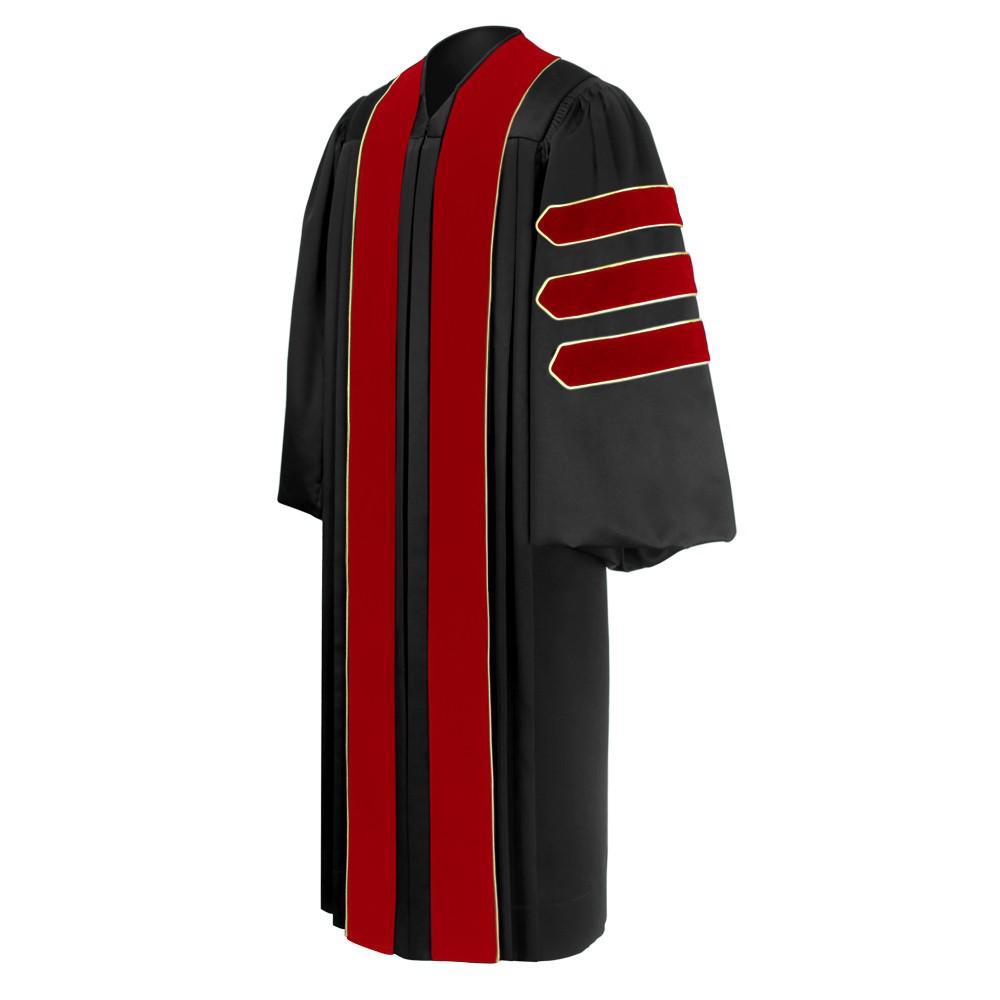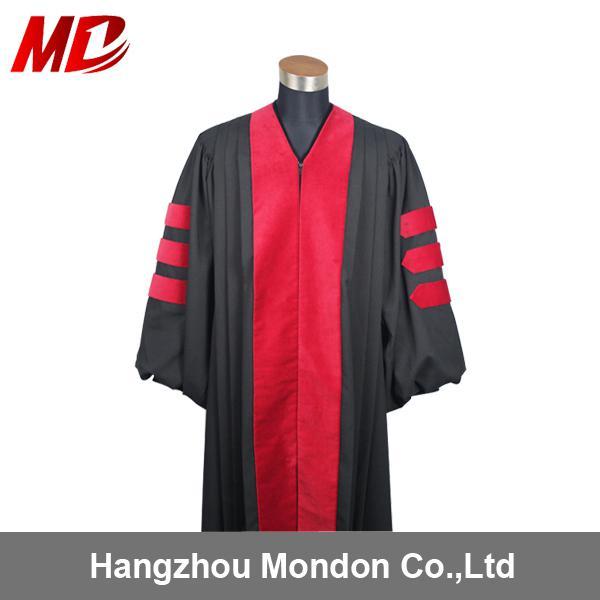The first image is the image on the left, the second image is the image on the right. Considering the images on both sides, is "There is at least one unworn academic gown facing slightly to the right." valid? Answer yes or no. No. The first image is the image on the left, the second image is the image on the right. Evaluate the accuracy of this statement regarding the images: "One image shows a purple and black gown angled facing slightly rightward.". Is it true? Answer yes or no. No. 